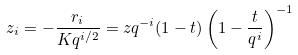<formula> <loc_0><loc_0><loc_500><loc_500>z _ { i } = - \frac { r _ { i } } { K q ^ { i / 2 } } = z q ^ { - i } ( 1 - t ) \left ( 1 - \frac { t } { q ^ { i } } \right ) ^ { - 1 }</formula> 